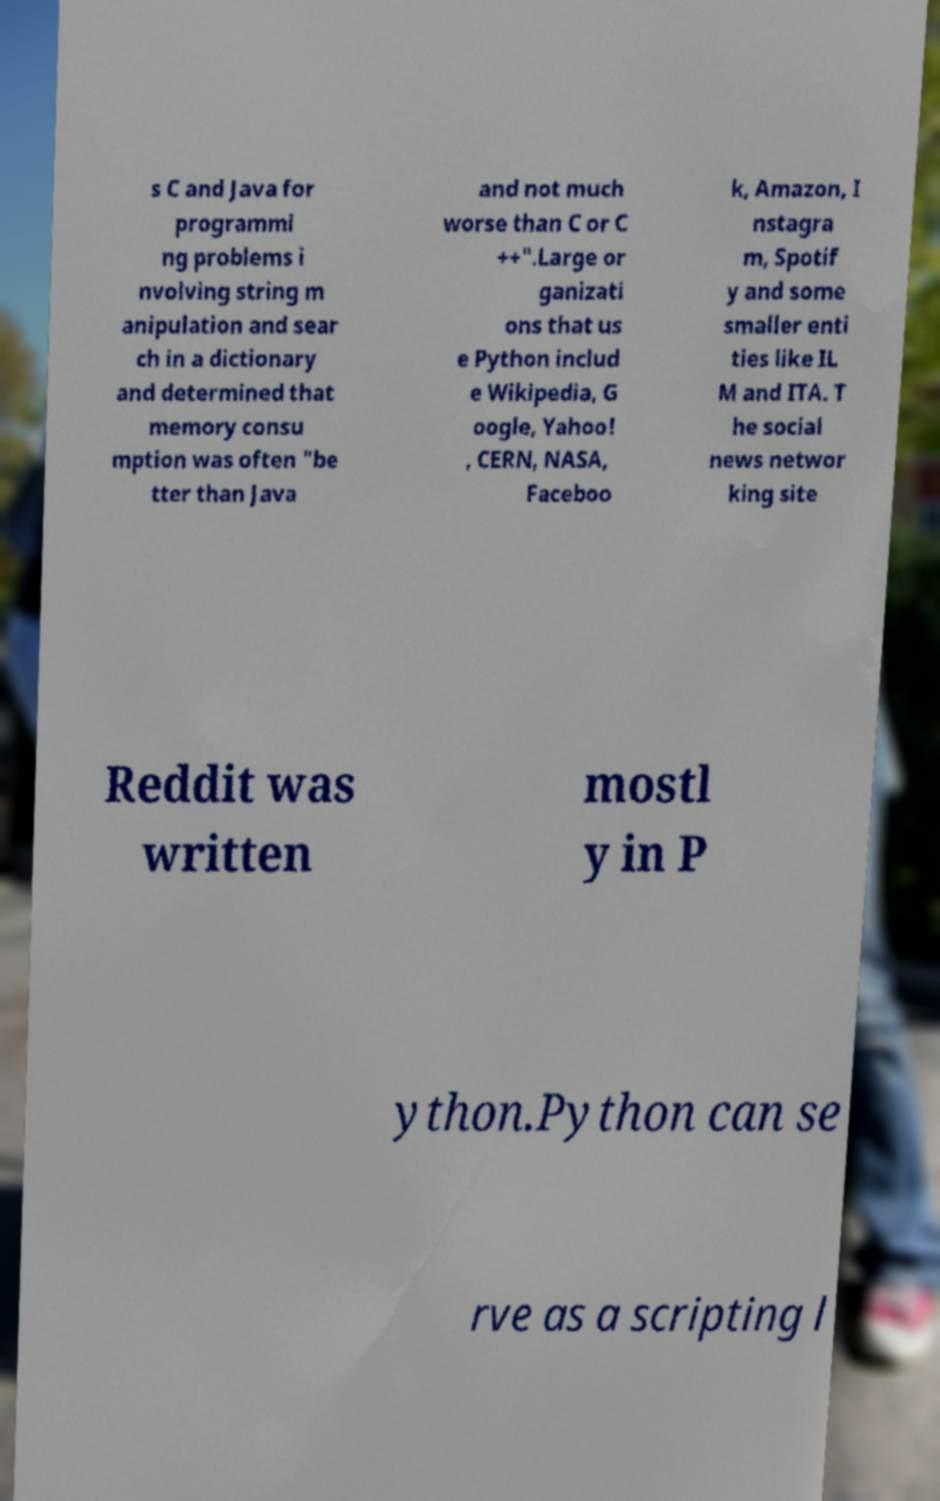Could you assist in decoding the text presented in this image and type it out clearly? s C and Java for programmi ng problems i nvolving string m anipulation and sear ch in a dictionary and determined that memory consu mption was often "be tter than Java and not much worse than C or C ++".Large or ganizati ons that us e Python includ e Wikipedia, G oogle, Yahoo! , CERN, NASA, Faceboo k, Amazon, I nstagra m, Spotif y and some smaller enti ties like IL M and ITA. T he social news networ king site Reddit was written mostl y in P ython.Python can se rve as a scripting l 